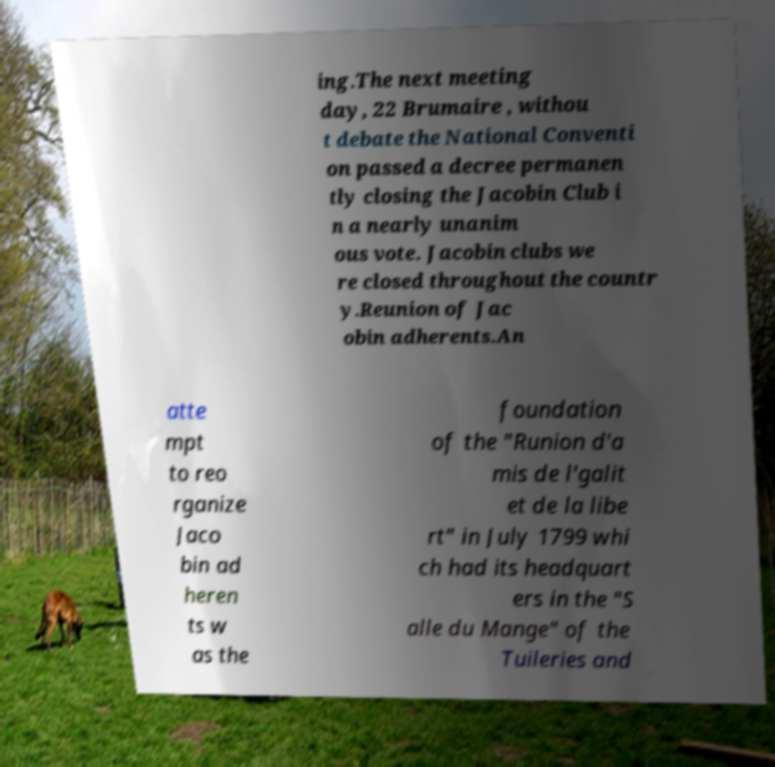For documentation purposes, I need the text within this image transcribed. Could you provide that? ing.The next meeting day, 22 Brumaire , withou t debate the National Conventi on passed a decree permanen tly closing the Jacobin Club i n a nearly unanim ous vote. Jacobin clubs we re closed throughout the countr y.Reunion of Jac obin adherents.An atte mpt to reo rganize Jaco bin ad heren ts w as the foundation of the "Runion d'a mis de l'galit et de la libe rt" in July 1799 whi ch had its headquart ers in the "S alle du Mange" of the Tuileries and 